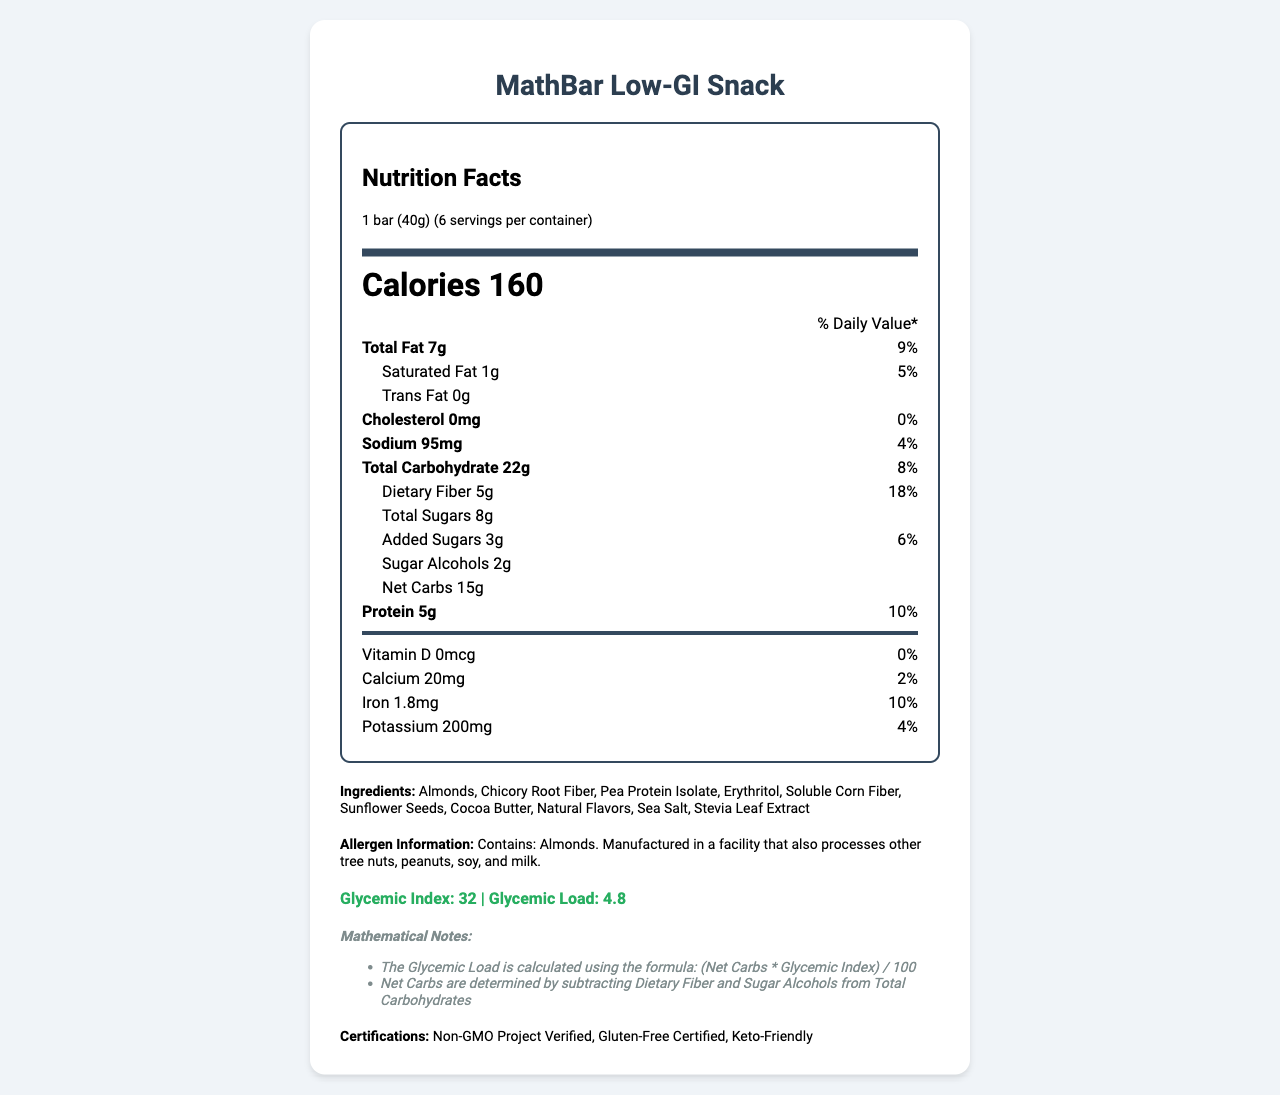what is the serving size of the MathBar Low-GI Snack? The serving size is mentioned in the document as "1 bar (40g)".
Answer: 1 bar (40g) how many servings are there per container of MathBar Low-GI Snack? The document states “6 servings per container”.
Answer: 6 how many calories are there per serving of MathBar Low-GI Snack? The document mentions "Calories 160" at the top after the serving size information.
Answer: 160 what is the total fat content per serving? The total fat content is stated as "Total Fat 7g".
Answer: 7g what is the amount of dietary fiber per serving? The dietary fiber is listed as "Dietary Fiber 5g".
Answer: 5g the MathBar Low-GI Snack contains which of these allergens? A. Peanuts B. Almonds C. Soy The allergen information specifies that the product contains almonds and is manufactured in a facility that processes other tree nuts, peanuts, soy, and milk.
Answer: B. Almonds the MathBar Low-GI Snack is certified as which of the following? A. Non-GMO B. Organic C. Vegan The certifications section lists "Non-GMO Project Verified".
Answer: A. Non-GMO does the MathBar Low-GI Snack contain any cholesterol? The document states "Cholesterol 0mg" and the daily value percentage is 0%.
Answer: No is the MathBar Low-GI Snack keto-friendly? The certifications section includes "Keto-Friendly".
Answer: Yes summarize the main nutritional points of the MathBar Low-GI Snack The document highlights that the MathBar Low-GI Snack offers balanced nutrition with low glycemic impact, making it suitable for keto diets and those seeking gluten-free snacks.
Answer: The MathBar Low-GI Snack is a low-glycemic index snack bar with a serving size of 1 bar (40g). Each serving contains 160 calories, 7g of total fat, 22g of total carbohydrate with 5g dietary fiber, 8g total sugars, and 2g sugar alcohols, resulting in 15g net carbs. Additionally, it has 5g of protein and is certified as Non-GMO Project Verified, Gluten-Free, and Keto-Friendly. The bar is made from ingredients like almonds, chicory root fiber, and pea protein isolate. It contains almonds and is produced in a facility handling various allergens. how do you calculate glycemic load based on the provided values? The mathematical notes in the document specify the formula for Glycemic Load as "(Net Carbs * Glycemic Index) / 100".
Answer: (Net Carbs * Glycemic Index) / 100 which vitamins and minerals are present in the MathBar Low-GI Snack? The document lists Vitamin D, Calcium, Iron, and Potassium under the vitamins section with their amounts and daily values.
Answer: Vitamin D, Calcium, Iron, Potassium what is the amount and daily value percentage of iron in the MathBar? The document specifies "Iron 1.8mg" with a daily value of 10%.
Answer: 1.8mg, 10% what are the net carbs in the MathBar Low-GI Snack? Net carbs is listed as 15g under the carbohydrate breakdown.
Answer: 15g how much sugar alcohol does the MathBar contain per serving? The sugar alcohol content is mentioned as "Sugar Alcohols 2g".
Answer: 2g what is the total daily value for saturated fat per serving? The saturated fat is listed as 1g with a daily value of 5%.
Answer: 5% does the MathBar Low-GI Snack contain any animal-derived products? The document does not provide enough information to determine whether any of the listed ingredients are animal-derived.
Answer: Cannot be determined 